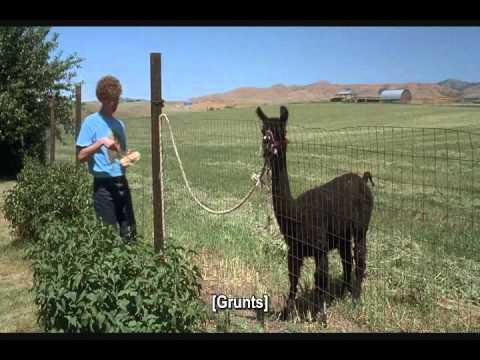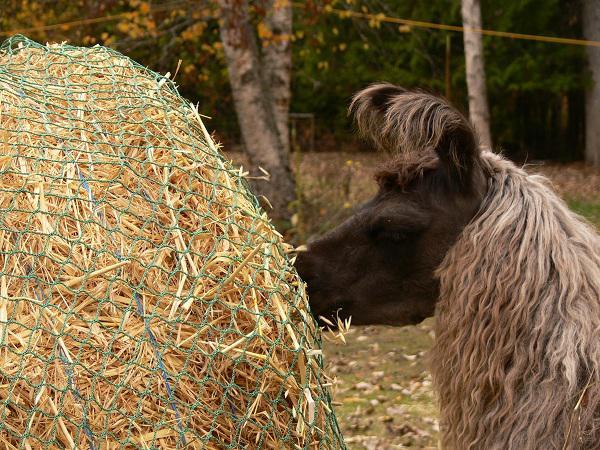The first image is the image on the left, the second image is the image on the right. For the images shown, is this caption "In at least one image there is a single brown llama eating yellow hay." true? Answer yes or no. Yes. 